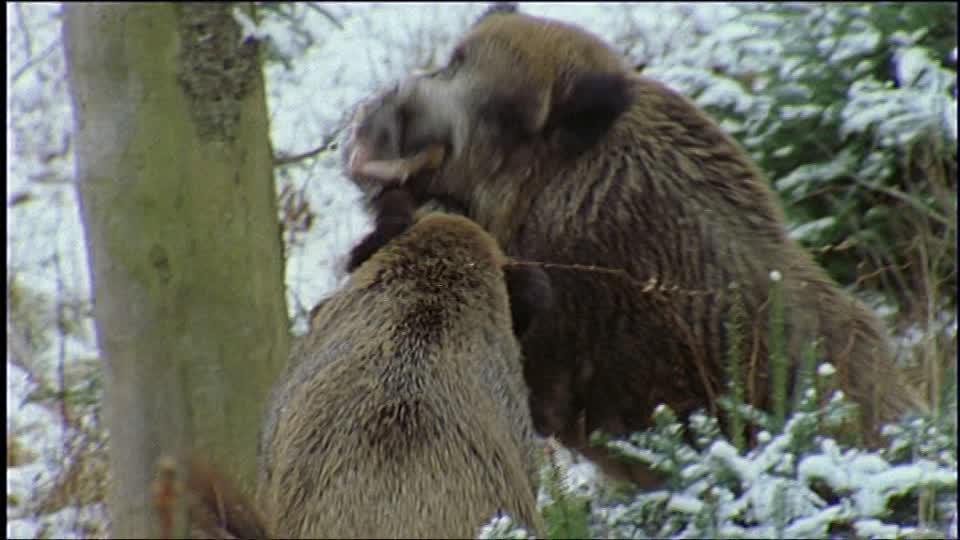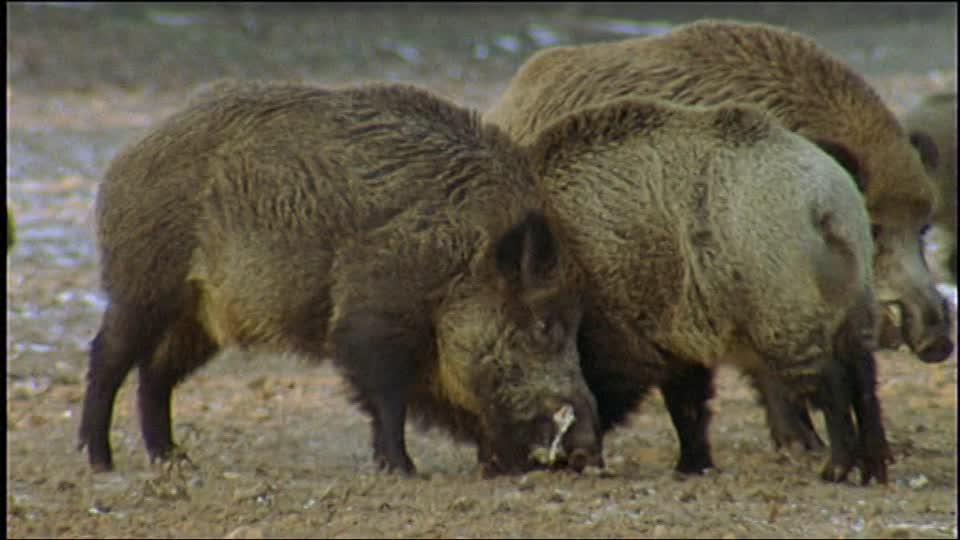The first image is the image on the left, the second image is the image on the right. Evaluate the accuracy of this statement regarding the images: "The right image shows at least three boars.". Is it true? Answer yes or no. Yes. 